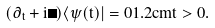<formula> <loc_0><loc_0><loc_500><loc_500>( \partial _ { t } + i \Omega ) \langle \psi ( t ) | = 0 1 . 2 c m t > 0 .</formula> 